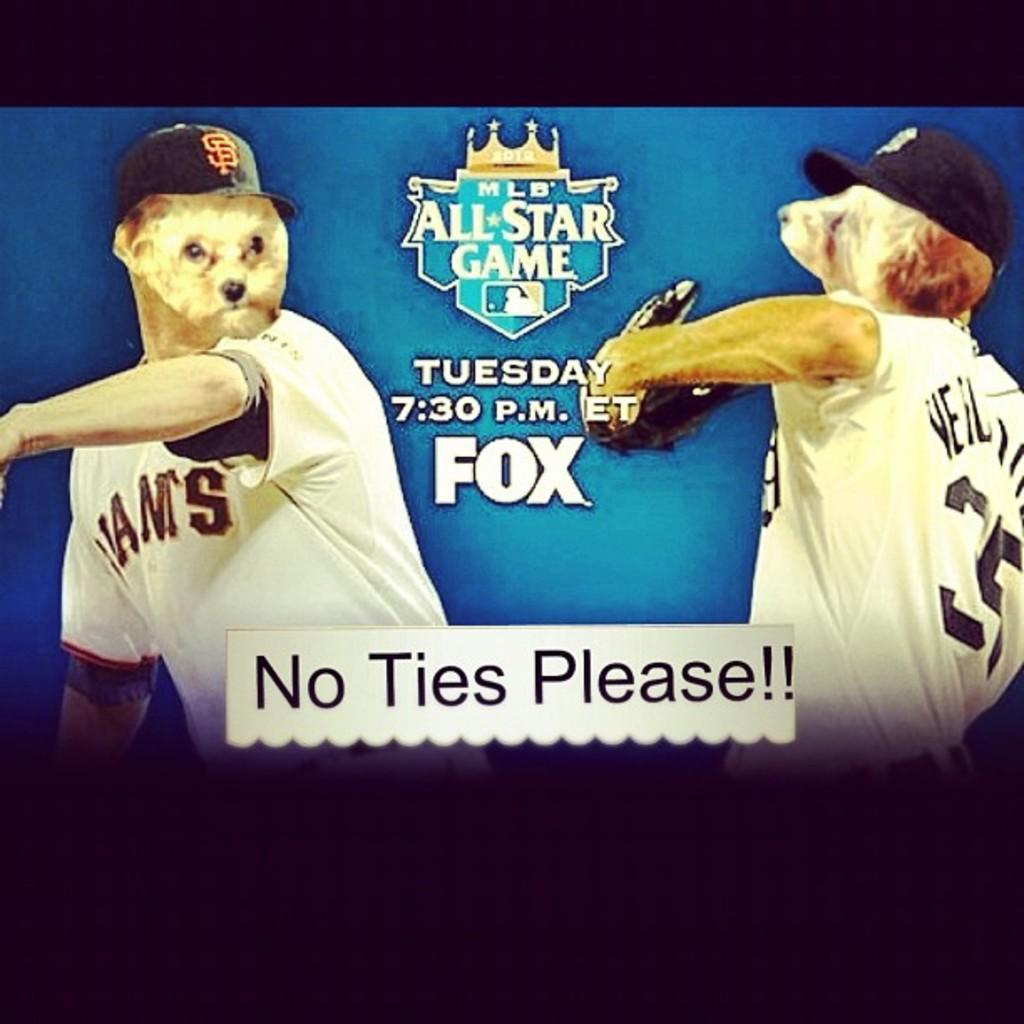<image>
Relay a brief, clear account of the picture shown. The All Star game instructs No Ties Please. 